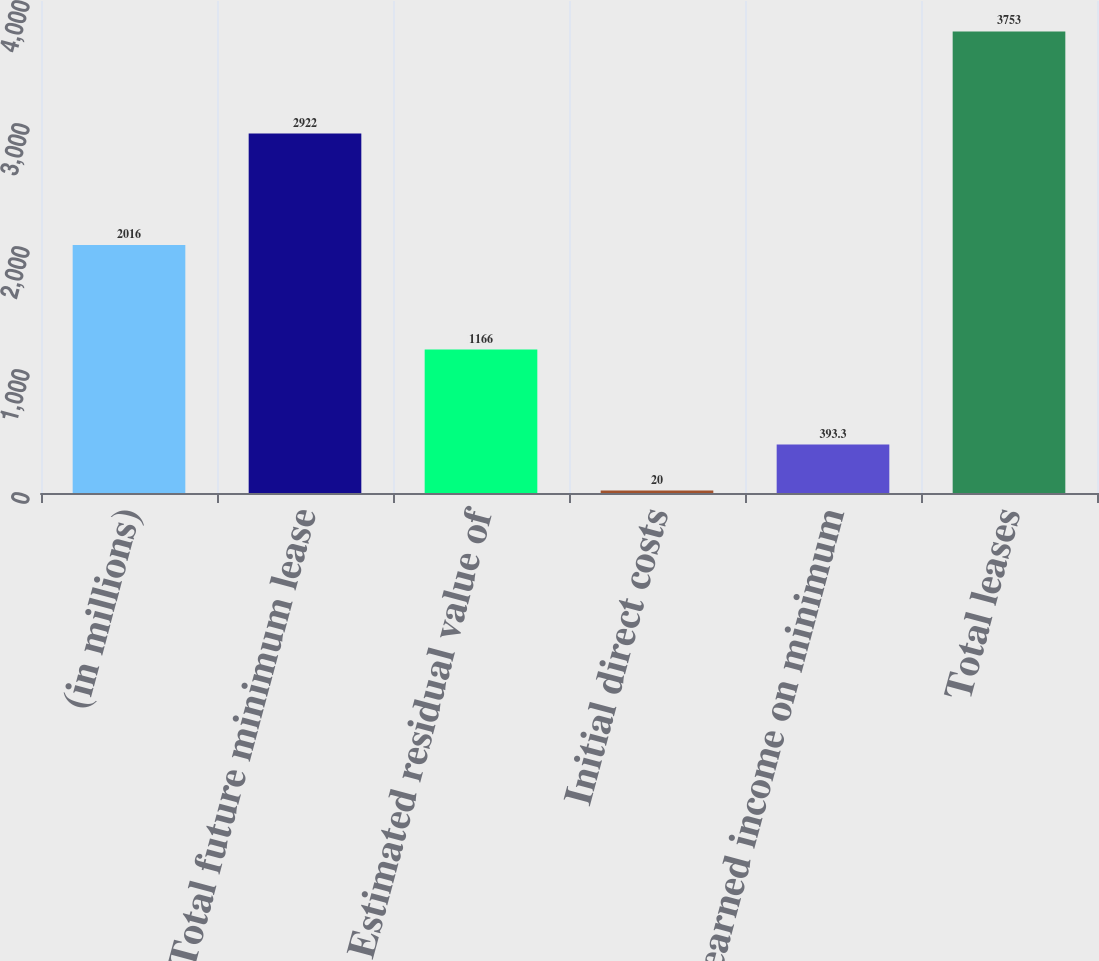Convert chart. <chart><loc_0><loc_0><loc_500><loc_500><bar_chart><fcel>(in millions)<fcel>Total future minimum lease<fcel>Estimated residual value of<fcel>Initial direct costs<fcel>Unearned income on minimum<fcel>Total leases<nl><fcel>2016<fcel>2922<fcel>1166<fcel>20<fcel>393.3<fcel>3753<nl></chart> 